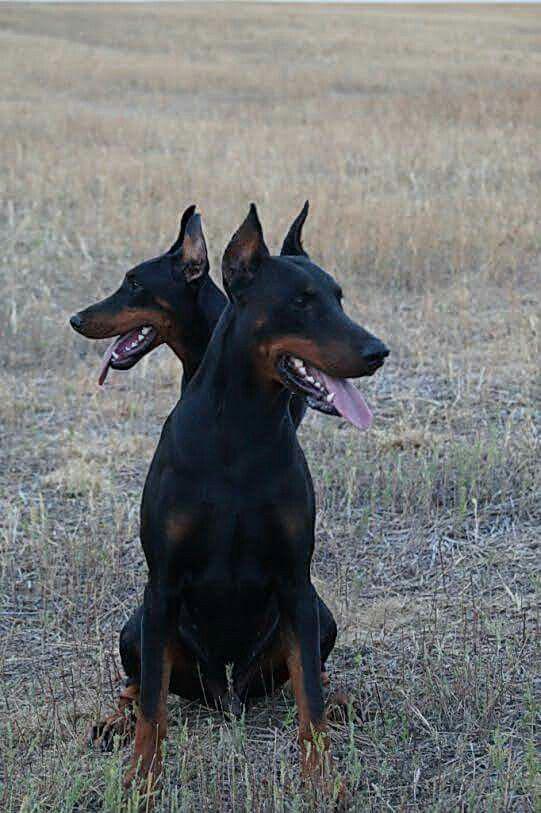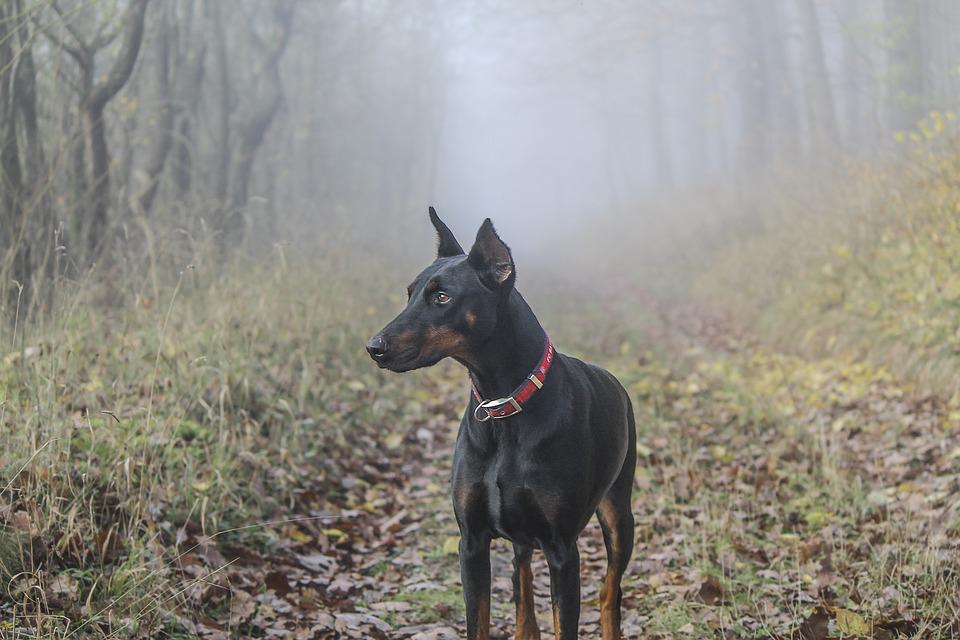The first image is the image on the left, the second image is the image on the right. Analyze the images presented: Is the assertion "All dogs shown are erect-eared dobermans gazing off to the side, and at least one dog is wearing a red collar and has a closed mouth." valid? Answer yes or no. Yes. The first image is the image on the left, the second image is the image on the right. Given the left and right images, does the statement "The dog in the image on the right has its mouth open." hold true? Answer yes or no. No. 